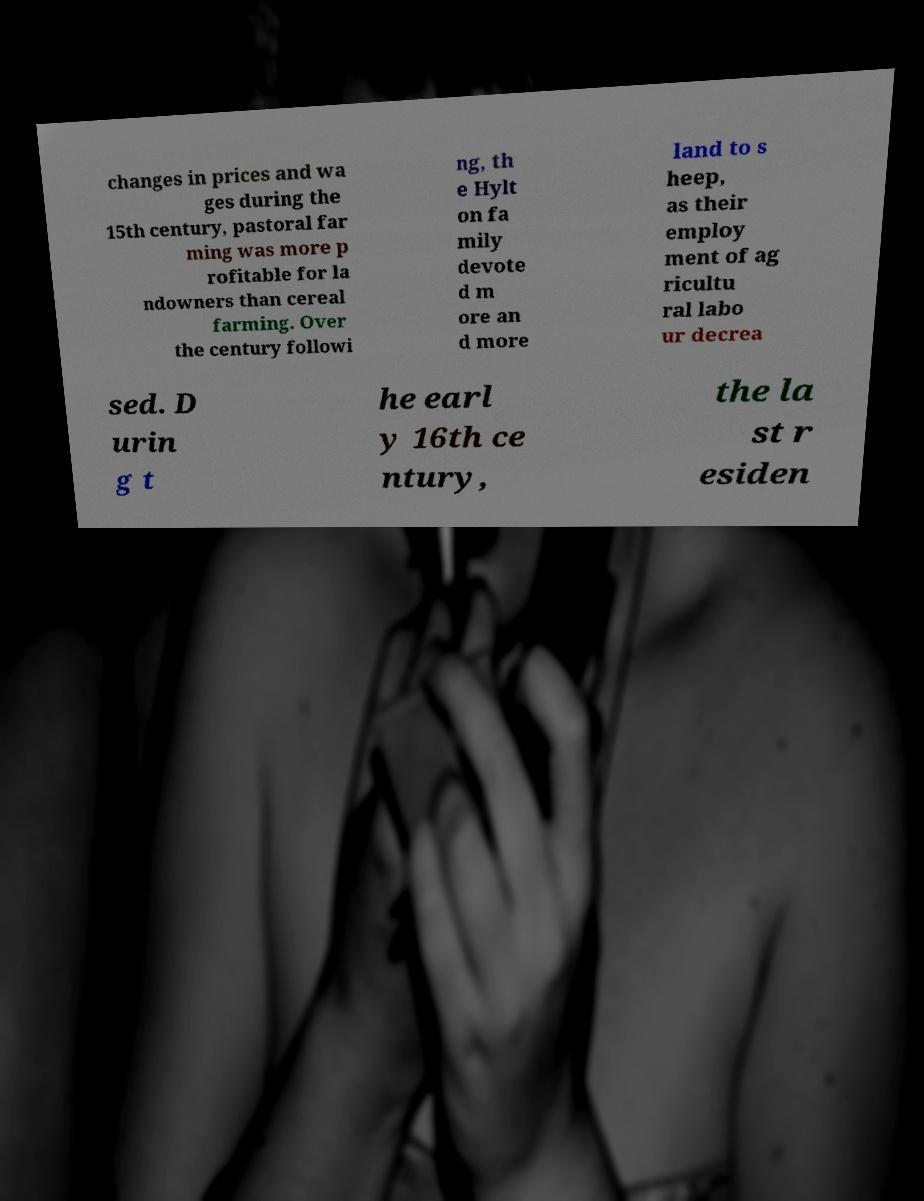Could you assist in decoding the text presented in this image and type it out clearly? changes in prices and wa ges during the 15th century, pastoral far ming was more p rofitable for la ndowners than cereal farming. Over the century followi ng, th e Hylt on fa mily devote d m ore an d more land to s heep, as their employ ment of ag ricultu ral labo ur decrea sed. D urin g t he earl y 16th ce ntury, the la st r esiden 